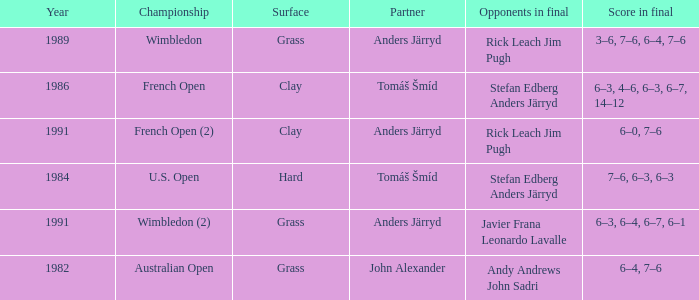Who was his partner in 1989?  Anders Järryd. 